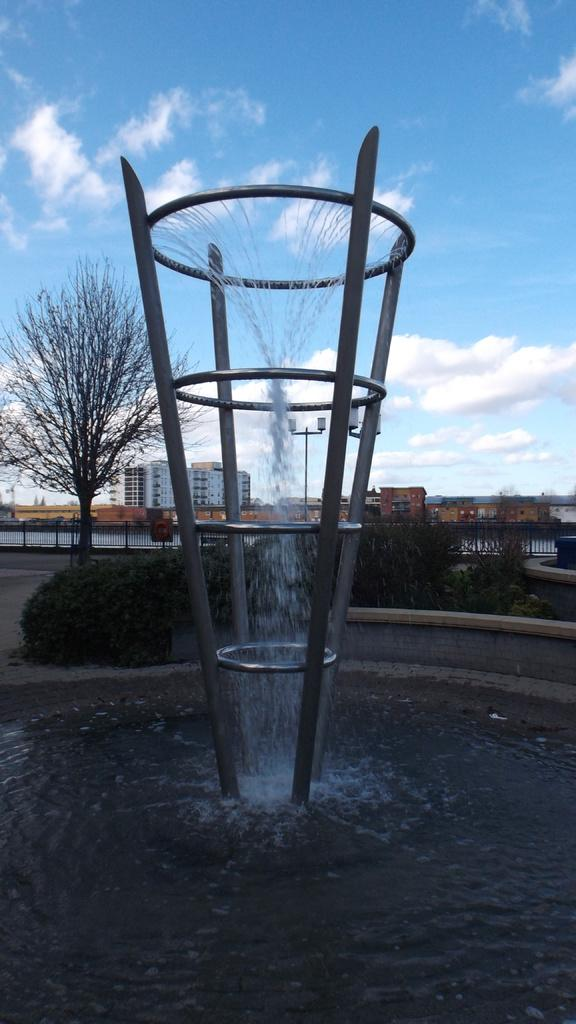What can be seen in the background of the image? There is a sky in the image. What is present in the sky? There are clouds in the sky. What type of structures are visible in the image? There are buildings in the image. What type of vegetation can be seen in the image? There are trees and bushes in the image. What type of water feature is present in the image? There is a fountain in the image. Where is the nearest store to the fountain in the image? There is no store present in the image, so it is not possible to determine its location relative to the fountain. 